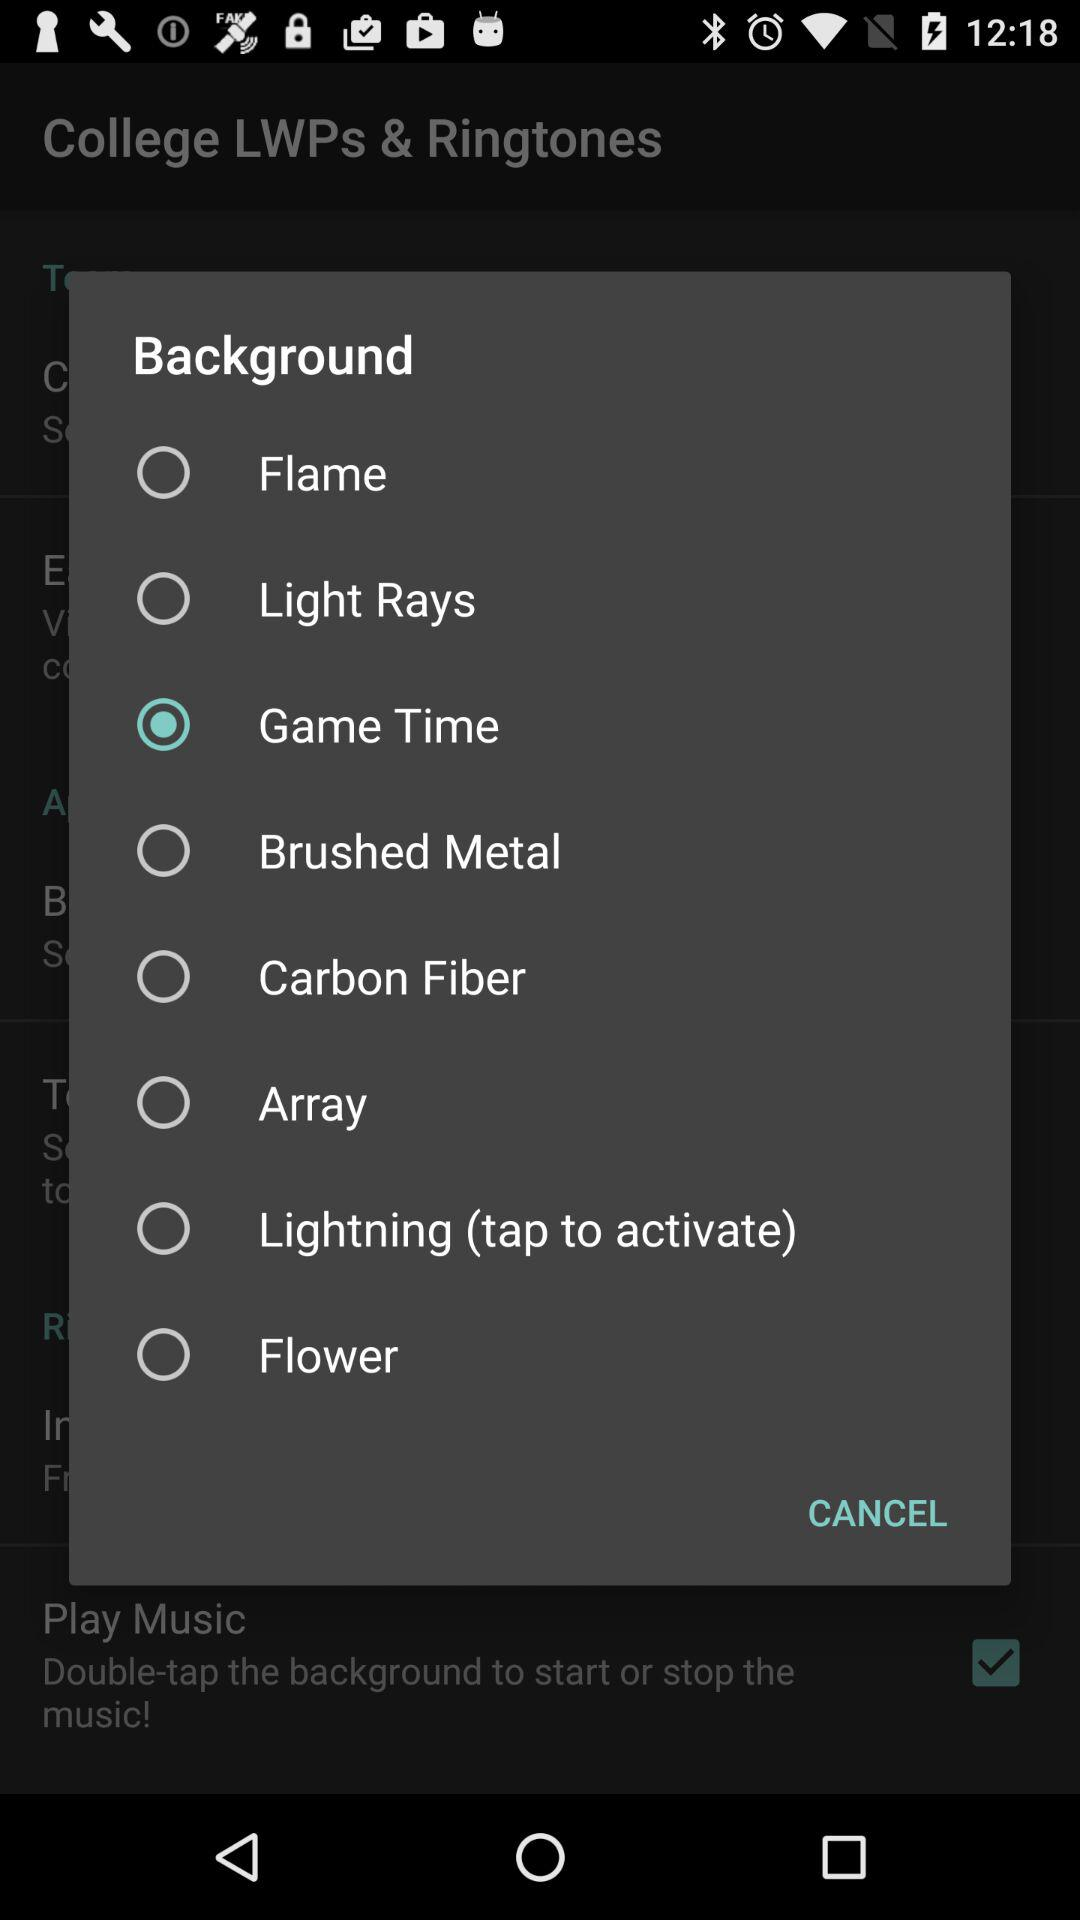Which option has been selected? The option that has been selected is "Game Time". 